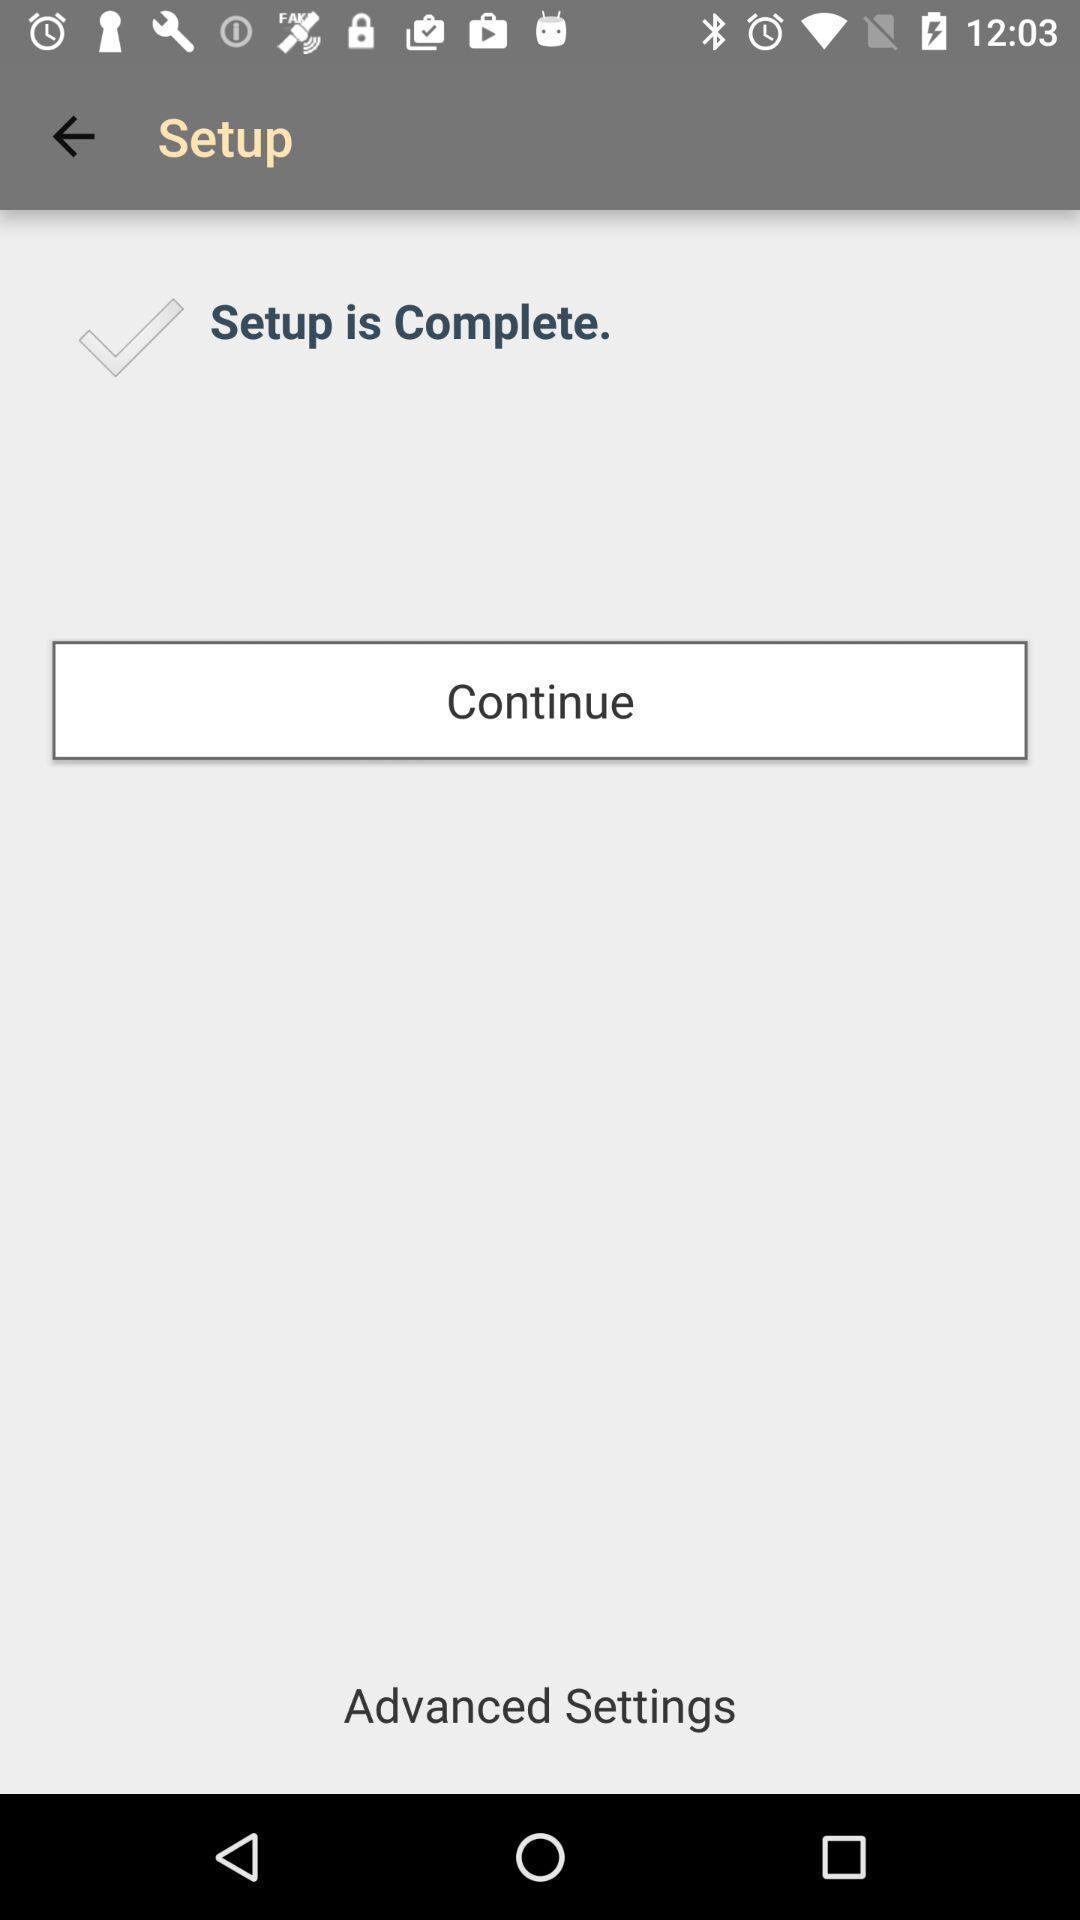Explain the elements present in this screenshot. Page showing option like continue. 